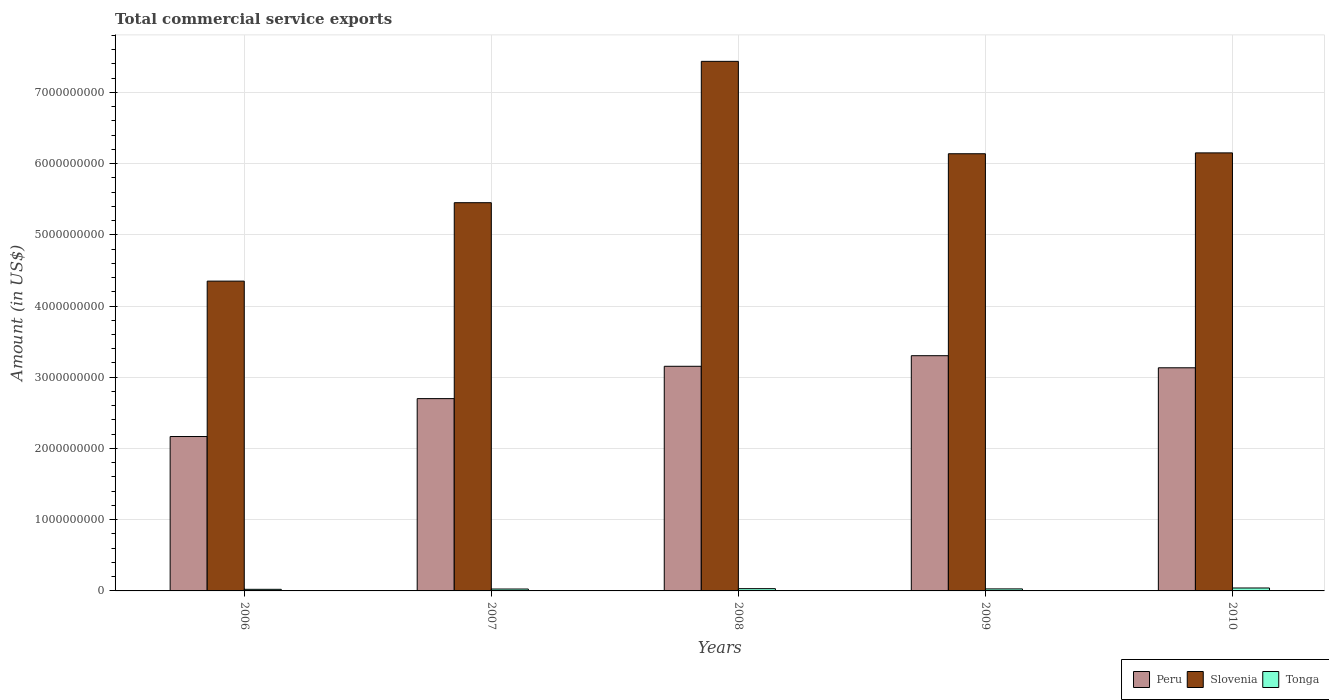How many different coloured bars are there?
Offer a very short reply. 3. What is the label of the 1st group of bars from the left?
Provide a succinct answer. 2006. In how many cases, is the number of bars for a given year not equal to the number of legend labels?
Offer a terse response. 0. What is the total commercial service exports in Slovenia in 2006?
Offer a very short reply. 4.35e+09. Across all years, what is the maximum total commercial service exports in Peru?
Provide a short and direct response. 3.30e+09. Across all years, what is the minimum total commercial service exports in Tonga?
Ensure brevity in your answer.  2.24e+07. What is the total total commercial service exports in Tonga in the graph?
Provide a short and direct response. 1.51e+08. What is the difference between the total commercial service exports in Slovenia in 2007 and that in 2008?
Ensure brevity in your answer.  -1.98e+09. What is the difference between the total commercial service exports in Peru in 2008 and the total commercial service exports in Slovenia in 2009?
Your answer should be compact. -2.98e+09. What is the average total commercial service exports in Peru per year?
Offer a very short reply. 2.89e+09. In the year 2009, what is the difference between the total commercial service exports in Peru and total commercial service exports in Slovenia?
Your answer should be compact. -2.84e+09. What is the ratio of the total commercial service exports in Peru in 2006 to that in 2010?
Keep it short and to the point. 0.69. Is the difference between the total commercial service exports in Peru in 2006 and 2008 greater than the difference between the total commercial service exports in Slovenia in 2006 and 2008?
Your response must be concise. Yes. What is the difference between the highest and the second highest total commercial service exports in Peru?
Keep it short and to the point. 1.49e+08. What is the difference between the highest and the lowest total commercial service exports in Peru?
Your answer should be compact. 1.13e+09. In how many years, is the total commercial service exports in Tonga greater than the average total commercial service exports in Tonga taken over all years?
Provide a succinct answer. 2. What does the 3rd bar from the left in 2010 represents?
Make the answer very short. Tonga. What does the 3rd bar from the right in 2007 represents?
Provide a short and direct response. Peru. Is it the case that in every year, the sum of the total commercial service exports in Tonga and total commercial service exports in Peru is greater than the total commercial service exports in Slovenia?
Offer a very short reply. No. How many bars are there?
Make the answer very short. 15. Are all the bars in the graph horizontal?
Keep it short and to the point. No. What is the difference between two consecutive major ticks on the Y-axis?
Provide a short and direct response. 1.00e+09. Does the graph contain any zero values?
Keep it short and to the point. No. Does the graph contain grids?
Give a very brief answer. Yes. Where does the legend appear in the graph?
Provide a short and direct response. Bottom right. What is the title of the graph?
Make the answer very short. Total commercial service exports. What is the label or title of the Y-axis?
Give a very brief answer. Amount (in US$). What is the Amount (in US$) in Peru in 2006?
Give a very brief answer. 2.17e+09. What is the Amount (in US$) of Slovenia in 2006?
Give a very brief answer. 4.35e+09. What is the Amount (in US$) of Tonga in 2006?
Your response must be concise. 2.24e+07. What is the Amount (in US$) of Peru in 2007?
Your response must be concise. 2.70e+09. What is the Amount (in US$) of Slovenia in 2007?
Keep it short and to the point. 5.45e+09. What is the Amount (in US$) in Tonga in 2007?
Provide a succinct answer. 2.67e+07. What is the Amount (in US$) in Peru in 2008?
Your response must be concise. 3.15e+09. What is the Amount (in US$) in Slovenia in 2008?
Your answer should be very brief. 7.43e+09. What is the Amount (in US$) of Tonga in 2008?
Offer a very short reply. 3.19e+07. What is the Amount (in US$) of Peru in 2009?
Keep it short and to the point. 3.30e+09. What is the Amount (in US$) in Slovenia in 2009?
Your answer should be very brief. 6.14e+09. What is the Amount (in US$) of Tonga in 2009?
Your response must be concise. 2.85e+07. What is the Amount (in US$) of Peru in 2010?
Offer a terse response. 3.13e+09. What is the Amount (in US$) of Slovenia in 2010?
Your answer should be compact. 6.15e+09. What is the Amount (in US$) in Tonga in 2010?
Provide a short and direct response. 4.11e+07. Across all years, what is the maximum Amount (in US$) in Peru?
Your response must be concise. 3.30e+09. Across all years, what is the maximum Amount (in US$) in Slovenia?
Your answer should be compact. 7.43e+09. Across all years, what is the maximum Amount (in US$) of Tonga?
Your answer should be compact. 4.11e+07. Across all years, what is the minimum Amount (in US$) of Peru?
Offer a terse response. 2.17e+09. Across all years, what is the minimum Amount (in US$) in Slovenia?
Give a very brief answer. 4.35e+09. Across all years, what is the minimum Amount (in US$) of Tonga?
Ensure brevity in your answer.  2.24e+07. What is the total Amount (in US$) in Peru in the graph?
Your answer should be compact. 1.45e+1. What is the total Amount (in US$) of Slovenia in the graph?
Offer a very short reply. 2.95e+1. What is the total Amount (in US$) of Tonga in the graph?
Provide a succinct answer. 1.51e+08. What is the difference between the Amount (in US$) of Peru in 2006 and that in 2007?
Offer a terse response. -5.32e+08. What is the difference between the Amount (in US$) in Slovenia in 2006 and that in 2007?
Keep it short and to the point. -1.10e+09. What is the difference between the Amount (in US$) of Tonga in 2006 and that in 2007?
Provide a short and direct response. -4.26e+06. What is the difference between the Amount (in US$) in Peru in 2006 and that in 2008?
Give a very brief answer. -9.86e+08. What is the difference between the Amount (in US$) of Slovenia in 2006 and that in 2008?
Provide a short and direct response. -3.09e+09. What is the difference between the Amount (in US$) of Tonga in 2006 and that in 2008?
Offer a terse response. -9.42e+06. What is the difference between the Amount (in US$) of Peru in 2006 and that in 2009?
Offer a very short reply. -1.13e+09. What is the difference between the Amount (in US$) in Slovenia in 2006 and that in 2009?
Provide a succinct answer. -1.79e+09. What is the difference between the Amount (in US$) in Tonga in 2006 and that in 2009?
Offer a very short reply. -6.03e+06. What is the difference between the Amount (in US$) in Peru in 2006 and that in 2010?
Your answer should be compact. -9.65e+08. What is the difference between the Amount (in US$) in Slovenia in 2006 and that in 2010?
Ensure brevity in your answer.  -1.80e+09. What is the difference between the Amount (in US$) of Tonga in 2006 and that in 2010?
Your answer should be very brief. -1.87e+07. What is the difference between the Amount (in US$) of Peru in 2007 and that in 2008?
Give a very brief answer. -4.54e+08. What is the difference between the Amount (in US$) in Slovenia in 2007 and that in 2008?
Keep it short and to the point. -1.98e+09. What is the difference between the Amount (in US$) of Tonga in 2007 and that in 2008?
Offer a terse response. -5.17e+06. What is the difference between the Amount (in US$) in Peru in 2007 and that in 2009?
Provide a succinct answer. -6.03e+08. What is the difference between the Amount (in US$) in Slovenia in 2007 and that in 2009?
Keep it short and to the point. -6.87e+08. What is the difference between the Amount (in US$) of Tonga in 2007 and that in 2009?
Your answer should be compact. -1.77e+06. What is the difference between the Amount (in US$) of Peru in 2007 and that in 2010?
Give a very brief answer. -4.33e+08. What is the difference between the Amount (in US$) in Slovenia in 2007 and that in 2010?
Give a very brief answer. -6.99e+08. What is the difference between the Amount (in US$) of Tonga in 2007 and that in 2010?
Offer a very short reply. -1.44e+07. What is the difference between the Amount (in US$) of Peru in 2008 and that in 2009?
Keep it short and to the point. -1.49e+08. What is the difference between the Amount (in US$) in Slovenia in 2008 and that in 2009?
Give a very brief answer. 1.30e+09. What is the difference between the Amount (in US$) in Tonga in 2008 and that in 2009?
Give a very brief answer. 3.40e+06. What is the difference between the Amount (in US$) of Peru in 2008 and that in 2010?
Make the answer very short. 2.10e+07. What is the difference between the Amount (in US$) of Slovenia in 2008 and that in 2010?
Your answer should be compact. 1.29e+09. What is the difference between the Amount (in US$) in Tonga in 2008 and that in 2010?
Your answer should be very brief. -9.24e+06. What is the difference between the Amount (in US$) in Peru in 2009 and that in 2010?
Ensure brevity in your answer.  1.70e+08. What is the difference between the Amount (in US$) of Slovenia in 2009 and that in 2010?
Provide a short and direct response. -1.21e+07. What is the difference between the Amount (in US$) of Tonga in 2009 and that in 2010?
Offer a terse response. -1.26e+07. What is the difference between the Amount (in US$) in Peru in 2006 and the Amount (in US$) in Slovenia in 2007?
Give a very brief answer. -3.28e+09. What is the difference between the Amount (in US$) of Peru in 2006 and the Amount (in US$) of Tonga in 2007?
Provide a short and direct response. 2.14e+09. What is the difference between the Amount (in US$) in Slovenia in 2006 and the Amount (in US$) in Tonga in 2007?
Provide a short and direct response. 4.32e+09. What is the difference between the Amount (in US$) of Peru in 2006 and the Amount (in US$) of Slovenia in 2008?
Provide a short and direct response. -5.27e+09. What is the difference between the Amount (in US$) in Peru in 2006 and the Amount (in US$) in Tonga in 2008?
Keep it short and to the point. 2.14e+09. What is the difference between the Amount (in US$) of Slovenia in 2006 and the Amount (in US$) of Tonga in 2008?
Give a very brief answer. 4.32e+09. What is the difference between the Amount (in US$) in Peru in 2006 and the Amount (in US$) in Slovenia in 2009?
Offer a terse response. -3.97e+09. What is the difference between the Amount (in US$) in Peru in 2006 and the Amount (in US$) in Tonga in 2009?
Offer a terse response. 2.14e+09. What is the difference between the Amount (in US$) of Slovenia in 2006 and the Amount (in US$) of Tonga in 2009?
Give a very brief answer. 4.32e+09. What is the difference between the Amount (in US$) of Peru in 2006 and the Amount (in US$) of Slovenia in 2010?
Ensure brevity in your answer.  -3.98e+09. What is the difference between the Amount (in US$) of Peru in 2006 and the Amount (in US$) of Tonga in 2010?
Your response must be concise. 2.13e+09. What is the difference between the Amount (in US$) in Slovenia in 2006 and the Amount (in US$) in Tonga in 2010?
Offer a very short reply. 4.31e+09. What is the difference between the Amount (in US$) of Peru in 2007 and the Amount (in US$) of Slovenia in 2008?
Keep it short and to the point. -4.74e+09. What is the difference between the Amount (in US$) in Peru in 2007 and the Amount (in US$) in Tonga in 2008?
Provide a succinct answer. 2.67e+09. What is the difference between the Amount (in US$) in Slovenia in 2007 and the Amount (in US$) in Tonga in 2008?
Ensure brevity in your answer.  5.42e+09. What is the difference between the Amount (in US$) in Peru in 2007 and the Amount (in US$) in Slovenia in 2009?
Ensure brevity in your answer.  -3.44e+09. What is the difference between the Amount (in US$) in Peru in 2007 and the Amount (in US$) in Tonga in 2009?
Keep it short and to the point. 2.67e+09. What is the difference between the Amount (in US$) of Slovenia in 2007 and the Amount (in US$) of Tonga in 2009?
Offer a very short reply. 5.42e+09. What is the difference between the Amount (in US$) of Peru in 2007 and the Amount (in US$) of Slovenia in 2010?
Your response must be concise. -3.45e+09. What is the difference between the Amount (in US$) in Peru in 2007 and the Amount (in US$) in Tonga in 2010?
Keep it short and to the point. 2.66e+09. What is the difference between the Amount (in US$) in Slovenia in 2007 and the Amount (in US$) in Tonga in 2010?
Your response must be concise. 5.41e+09. What is the difference between the Amount (in US$) of Peru in 2008 and the Amount (in US$) of Slovenia in 2009?
Offer a very short reply. -2.98e+09. What is the difference between the Amount (in US$) in Peru in 2008 and the Amount (in US$) in Tonga in 2009?
Your answer should be very brief. 3.13e+09. What is the difference between the Amount (in US$) of Slovenia in 2008 and the Amount (in US$) of Tonga in 2009?
Offer a terse response. 7.41e+09. What is the difference between the Amount (in US$) of Peru in 2008 and the Amount (in US$) of Slovenia in 2010?
Your response must be concise. -3.00e+09. What is the difference between the Amount (in US$) of Peru in 2008 and the Amount (in US$) of Tonga in 2010?
Ensure brevity in your answer.  3.11e+09. What is the difference between the Amount (in US$) in Slovenia in 2008 and the Amount (in US$) in Tonga in 2010?
Offer a very short reply. 7.39e+09. What is the difference between the Amount (in US$) in Peru in 2009 and the Amount (in US$) in Slovenia in 2010?
Provide a short and direct response. -2.85e+09. What is the difference between the Amount (in US$) of Peru in 2009 and the Amount (in US$) of Tonga in 2010?
Give a very brief answer. 3.26e+09. What is the difference between the Amount (in US$) of Slovenia in 2009 and the Amount (in US$) of Tonga in 2010?
Offer a very short reply. 6.10e+09. What is the average Amount (in US$) of Peru per year?
Provide a short and direct response. 2.89e+09. What is the average Amount (in US$) of Slovenia per year?
Give a very brief answer. 5.90e+09. What is the average Amount (in US$) in Tonga per year?
Offer a terse response. 3.01e+07. In the year 2006, what is the difference between the Amount (in US$) of Peru and Amount (in US$) of Slovenia?
Your answer should be very brief. -2.18e+09. In the year 2006, what is the difference between the Amount (in US$) of Peru and Amount (in US$) of Tonga?
Your answer should be compact. 2.15e+09. In the year 2006, what is the difference between the Amount (in US$) in Slovenia and Amount (in US$) in Tonga?
Ensure brevity in your answer.  4.33e+09. In the year 2007, what is the difference between the Amount (in US$) in Peru and Amount (in US$) in Slovenia?
Offer a terse response. -2.75e+09. In the year 2007, what is the difference between the Amount (in US$) of Peru and Amount (in US$) of Tonga?
Provide a succinct answer. 2.67e+09. In the year 2007, what is the difference between the Amount (in US$) of Slovenia and Amount (in US$) of Tonga?
Provide a succinct answer. 5.42e+09. In the year 2008, what is the difference between the Amount (in US$) in Peru and Amount (in US$) in Slovenia?
Your answer should be compact. -4.28e+09. In the year 2008, what is the difference between the Amount (in US$) in Peru and Amount (in US$) in Tonga?
Ensure brevity in your answer.  3.12e+09. In the year 2008, what is the difference between the Amount (in US$) of Slovenia and Amount (in US$) of Tonga?
Provide a succinct answer. 7.40e+09. In the year 2009, what is the difference between the Amount (in US$) in Peru and Amount (in US$) in Slovenia?
Your response must be concise. -2.84e+09. In the year 2009, what is the difference between the Amount (in US$) in Peru and Amount (in US$) in Tonga?
Keep it short and to the point. 3.27e+09. In the year 2009, what is the difference between the Amount (in US$) of Slovenia and Amount (in US$) of Tonga?
Provide a short and direct response. 6.11e+09. In the year 2010, what is the difference between the Amount (in US$) of Peru and Amount (in US$) of Slovenia?
Your answer should be compact. -3.02e+09. In the year 2010, what is the difference between the Amount (in US$) in Peru and Amount (in US$) in Tonga?
Your answer should be very brief. 3.09e+09. In the year 2010, what is the difference between the Amount (in US$) in Slovenia and Amount (in US$) in Tonga?
Provide a succinct answer. 6.11e+09. What is the ratio of the Amount (in US$) of Peru in 2006 to that in 2007?
Your response must be concise. 0.8. What is the ratio of the Amount (in US$) of Slovenia in 2006 to that in 2007?
Provide a succinct answer. 0.8. What is the ratio of the Amount (in US$) of Tonga in 2006 to that in 2007?
Offer a very short reply. 0.84. What is the ratio of the Amount (in US$) of Peru in 2006 to that in 2008?
Offer a very short reply. 0.69. What is the ratio of the Amount (in US$) in Slovenia in 2006 to that in 2008?
Offer a terse response. 0.58. What is the ratio of the Amount (in US$) of Tonga in 2006 to that in 2008?
Provide a succinct answer. 0.7. What is the ratio of the Amount (in US$) in Peru in 2006 to that in 2009?
Offer a terse response. 0.66. What is the ratio of the Amount (in US$) of Slovenia in 2006 to that in 2009?
Offer a terse response. 0.71. What is the ratio of the Amount (in US$) in Tonga in 2006 to that in 2009?
Give a very brief answer. 0.79. What is the ratio of the Amount (in US$) of Peru in 2006 to that in 2010?
Ensure brevity in your answer.  0.69. What is the ratio of the Amount (in US$) of Slovenia in 2006 to that in 2010?
Your response must be concise. 0.71. What is the ratio of the Amount (in US$) of Tonga in 2006 to that in 2010?
Provide a short and direct response. 0.55. What is the ratio of the Amount (in US$) of Peru in 2007 to that in 2008?
Your answer should be very brief. 0.86. What is the ratio of the Amount (in US$) of Slovenia in 2007 to that in 2008?
Make the answer very short. 0.73. What is the ratio of the Amount (in US$) in Tonga in 2007 to that in 2008?
Give a very brief answer. 0.84. What is the ratio of the Amount (in US$) of Peru in 2007 to that in 2009?
Keep it short and to the point. 0.82. What is the ratio of the Amount (in US$) in Slovenia in 2007 to that in 2009?
Provide a succinct answer. 0.89. What is the ratio of the Amount (in US$) of Tonga in 2007 to that in 2009?
Provide a short and direct response. 0.94. What is the ratio of the Amount (in US$) of Peru in 2007 to that in 2010?
Keep it short and to the point. 0.86. What is the ratio of the Amount (in US$) in Slovenia in 2007 to that in 2010?
Offer a very short reply. 0.89. What is the ratio of the Amount (in US$) in Tonga in 2007 to that in 2010?
Your answer should be very brief. 0.65. What is the ratio of the Amount (in US$) of Peru in 2008 to that in 2009?
Keep it short and to the point. 0.95. What is the ratio of the Amount (in US$) of Slovenia in 2008 to that in 2009?
Provide a succinct answer. 1.21. What is the ratio of the Amount (in US$) in Tonga in 2008 to that in 2009?
Ensure brevity in your answer.  1.12. What is the ratio of the Amount (in US$) of Slovenia in 2008 to that in 2010?
Your answer should be compact. 1.21. What is the ratio of the Amount (in US$) of Tonga in 2008 to that in 2010?
Offer a very short reply. 0.78. What is the ratio of the Amount (in US$) of Peru in 2009 to that in 2010?
Offer a very short reply. 1.05. What is the ratio of the Amount (in US$) in Slovenia in 2009 to that in 2010?
Make the answer very short. 1. What is the ratio of the Amount (in US$) of Tonga in 2009 to that in 2010?
Your answer should be compact. 0.69. What is the difference between the highest and the second highest Amount (in US$) in Peru?
Ensure brevity in your answer.  1.49e+08. What is the difference between the highest and the second highest Amount (in US$) of Slovenia?
Keep it short and to the point. 1.29e+09. What is the difference between the highest and the second highest Amount (in US$) of Tonga?
Offer a terse response. 9.24e+06. What is the difference between the highest and the lowest Amount (in US$) of Peru?
Your response must be concise. 1.13e+09. What is the difference between the highest and the lowest Amount (in US$) in Slovenia?
Your response must be concise. 3.09e+09. What is the difference between the highest and the lowest Amount (in US$) in Tonga?
Provide a succinct answer. 1.87e+07. 